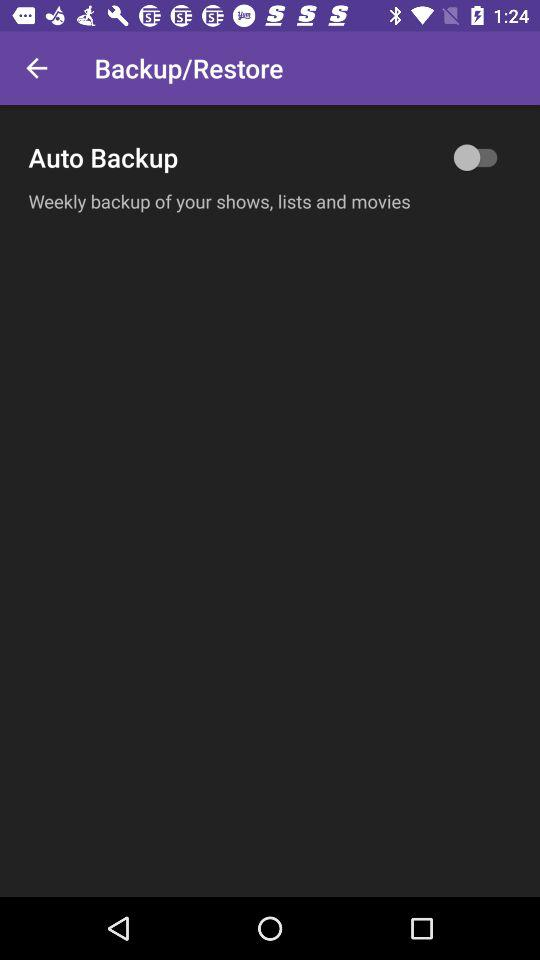How many days does the backup occur?
Answer the question using a single word or phrase. Weekly 